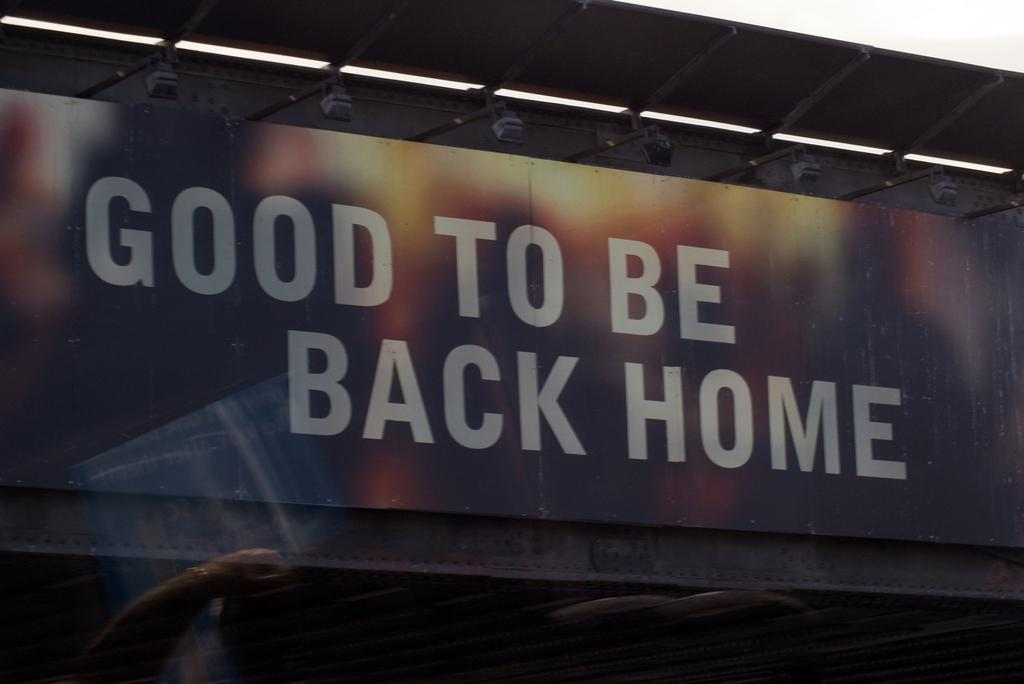<image>
Offer a succinct explanation of the picture presented. a billboard that says 'good to be back home' on it 